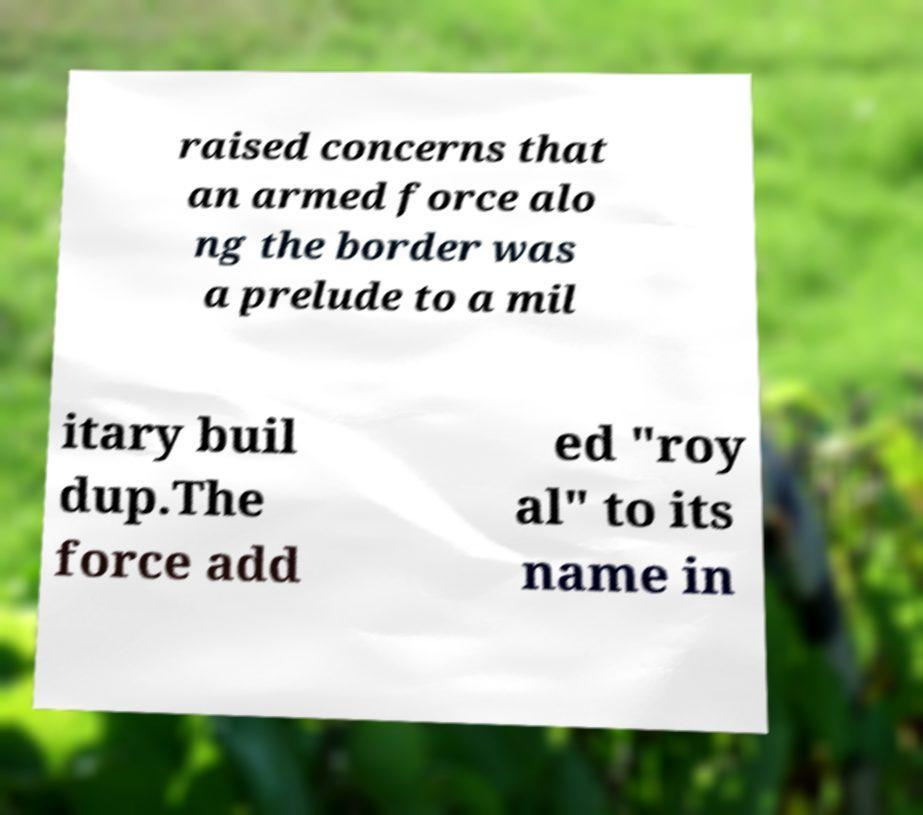Please identify and transcribe the text found in this image. raised concerns that an armed force alo ng the border was a prelude to a mil itary buil dup.The force add ed "roy al" to its name in 